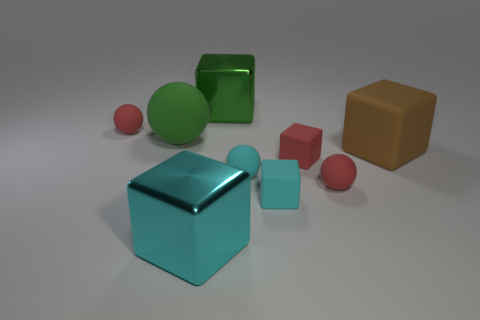Subtract 1 spheres. How many spheres are left? 3 Subtract all brown blocks. How many blocks are left? 4 Subtract all small red matte cubes. How many cubes are left? 4 Subtract all red blocks. Subtract all yellow spheres. How many blocks are left? 4 Add 1 green metal things. How many objects exist? 10 Subtract all balls. How many objects are left? 5 Subtract all brown blocks. Subtract all large cyan metallic blocks. How many objects are left? 7 Add 4 cyan things. How many cyan things are left? 7 Add 7 green balls. How many green balls exist? 8 Subtract 1 green spheres. How many objects are left? 8 